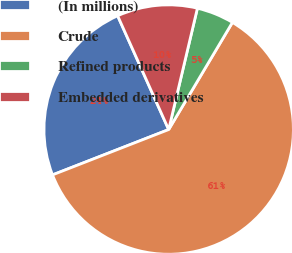Convert chart. <chart><loc_0><loc_0><loc_500><loc_500><pie_chart><fcel>(In millions)<fcel>Crude<fcel>Refined products<fcel>Embedded derivatives<nl><fcel>24.21%<fcel>60.53%<fcel>4.84%<fcel>10.41%<nl></chart> 